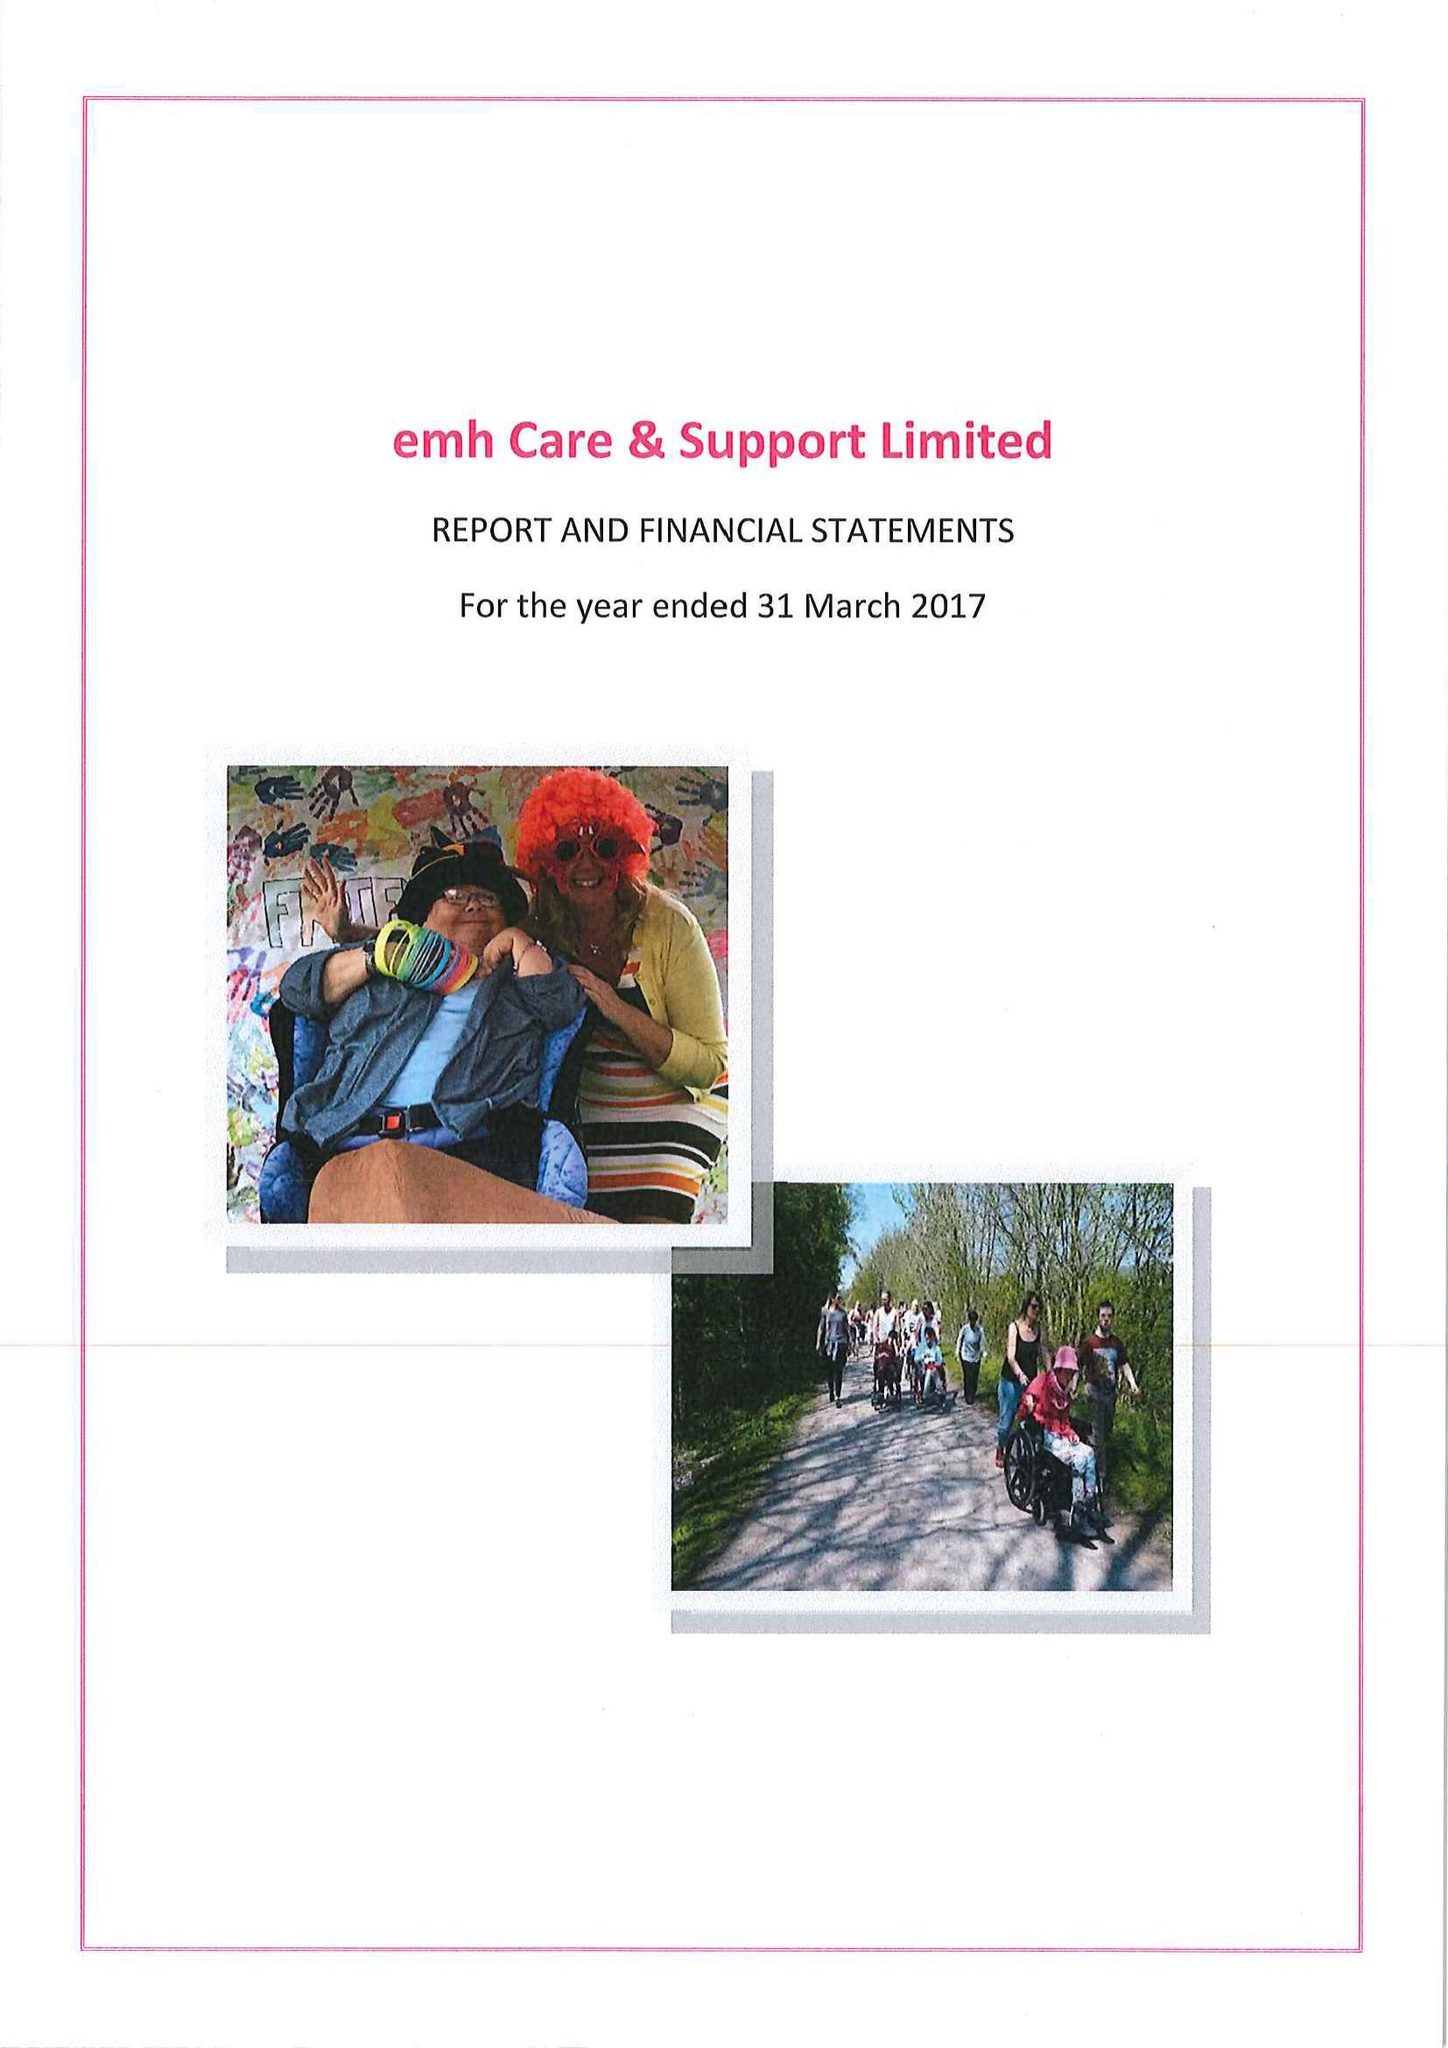What is the value for the charity_name?
Answer the question using a single word or phrase. Enable Care and Home Support Ltd. 